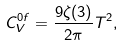<formula> <loc_0><loc_0><loc_500><loc_500>C _ { V } ^ { 0 f } = \frac { 9 \zeta ( 3 ) } { 2 \pi } T ^ { 2 } ,</formula> 